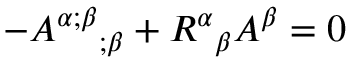<formula> <loc_0><loc_0><loc_500><loc_500>- { A ^ { \alpha ; \beta } } _ { ; \beta } + { R ^ { \alpha } } _ { \beta } A ^ { \beta } = 0</formula> 